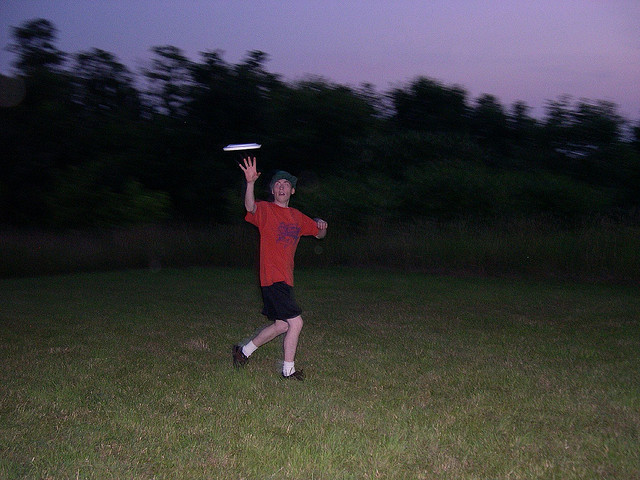<image>Which border is ahead? It is unknown which border is ahead. There is no indicator in the image. Which border is ahead? I don't know which border is ahead. It can be seen 'mexico' or 'none'. 